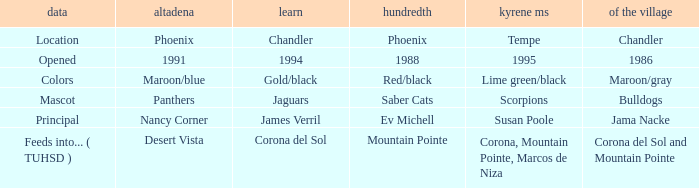Which Altadeña has a Aprende of jaguars? Panthers. 